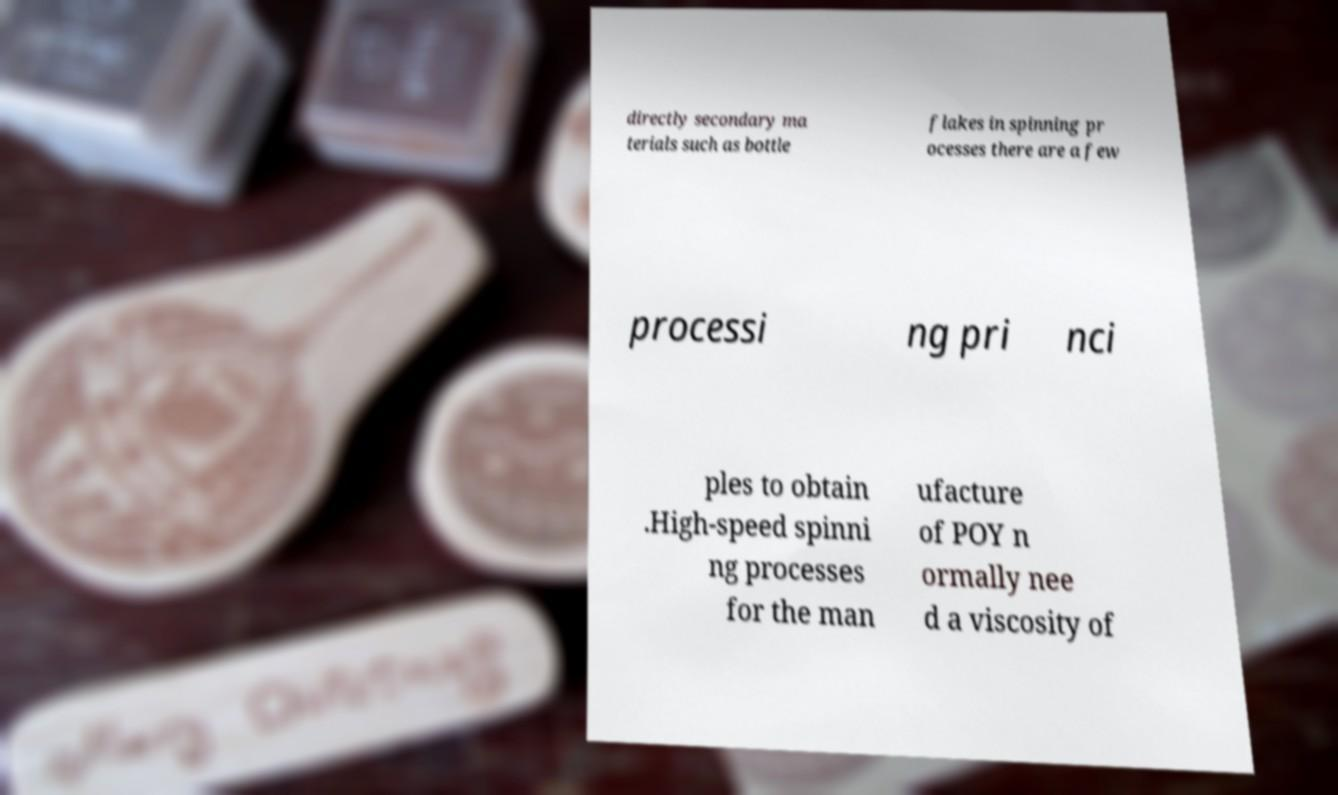I need the written content from this picture converted into text. Can you do that? directly secondary ma terials such as bottle flakes in spinning pr ocesses there are a few processi ng pri nci ples to obtain .High-speed spinni ng processes for the man ufacture of POY n ormally nee d a viscosity of 